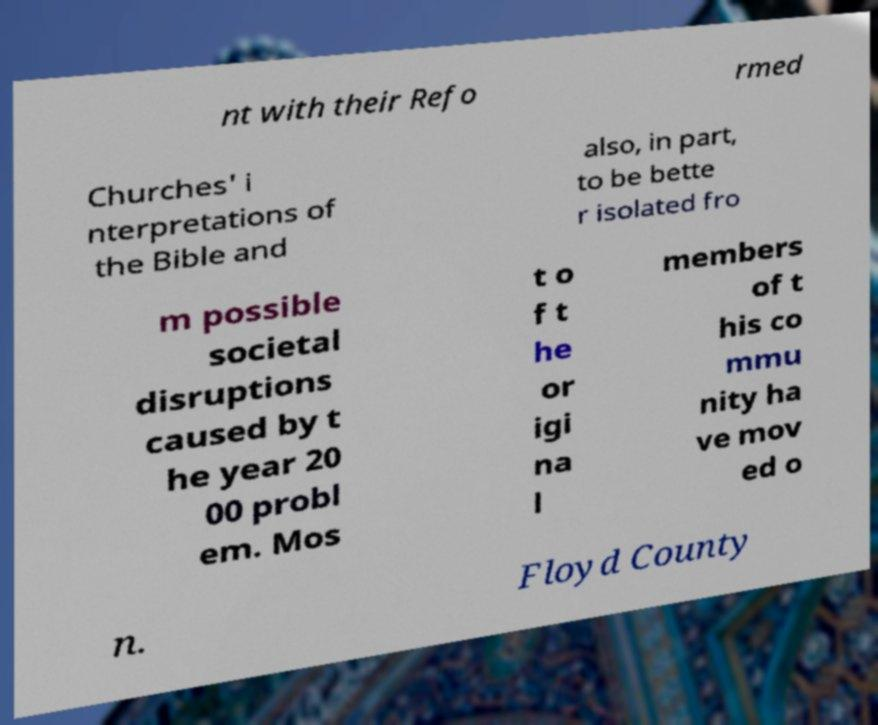Please read and relay the text visible in this image. What does it say? nt with their Refo rmed Churches' i nterpretations of the Bible and also, in part, to be bette r isolated fro m possible societal disruptions caused by t he year 20 00 probl em. Mos t o f t he or igi na l members of t his co mmu nity ha ve mov ed o n. Floyd County 